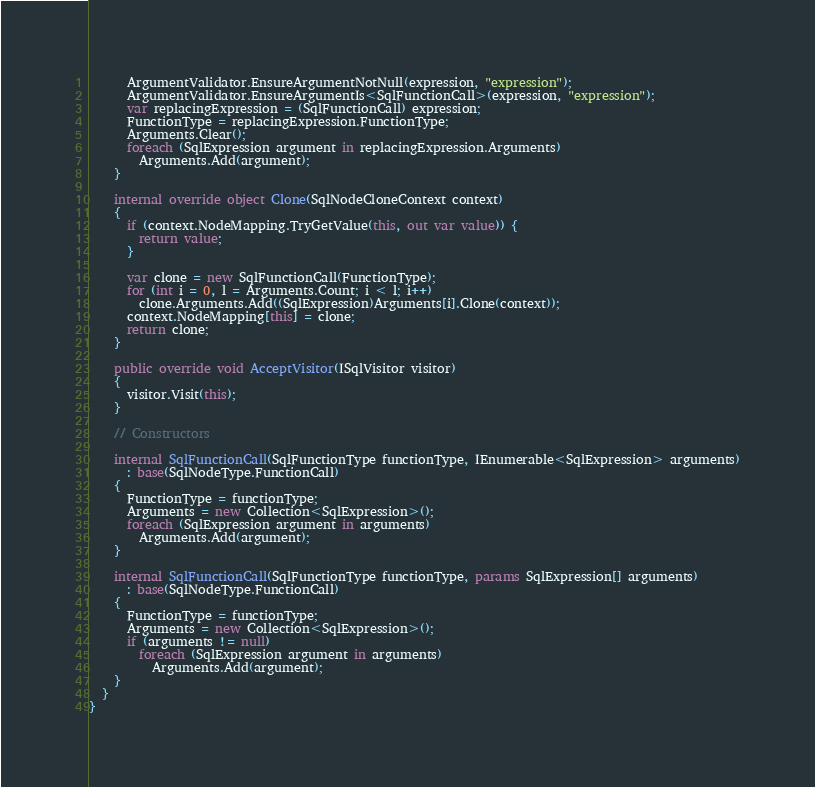Convert code to text. <code><loc_0><loc_0><loc_500><loc_500><_C#_>      ArgumentValidator.EnsureArgumentNotNull(expression, "expression");
      ArgumentValidator.EnsureArgumentIs<SqlFunctionCall>(expression, "expression");
      var replacingExpression = (SqlFunctionCall) expression;
      FunctionType = replacingExpression.FunctionType;
      Arguments.Clear();
      foreach (SqlExpression argument in replacingExpression.Arguments)
        Arguments.Add(argument);
    }

    internal override object Clone(SqlNodeCloneContext context)
    {
      if (context.NodeMapping.TryGetValue(this, out var value)) {
        return value;
      }

      var clone = new SqlFunctionCall(FunctionType);
      for (int i = 0, l = Arguments.Count; i < l; i++)
        clone.Arguments.Add((SqlExpression)Arguments[i].Clone(context));
      context.NodeMapping[this] = clone;
      return clone;
    }

    public override void AcceptVisitor(ISqlVisitor visitor)
    {
      visitor.Visit(this);
    }

    // Constructors

    internal SqlFunctionCall(SqlFunctionType functionType, IEnumerable<SqlExpression> arguments)
      : base(SqlNodeType.FunctionCall)
    {
      FunctionType = functionType;
      Arguments = new Collection<SqlExpression>();
      foreach (SqlExpression argument in arguments)
        Arguments.Add(argument);
    }

    internal SqlFunctionCall(SqlFunctionType functionType, params SqlExpression[] arguments)
      : base(SqlNodeType.FunctionCall)
    {
      FunctionType = functionType;
      Arguments = new Collection<SqlExpression>();
      if (arguments != null)
        foreach (SqlExpression argument in arguments)
          Arguments.Add(argument);
    }
  }
}</code> 